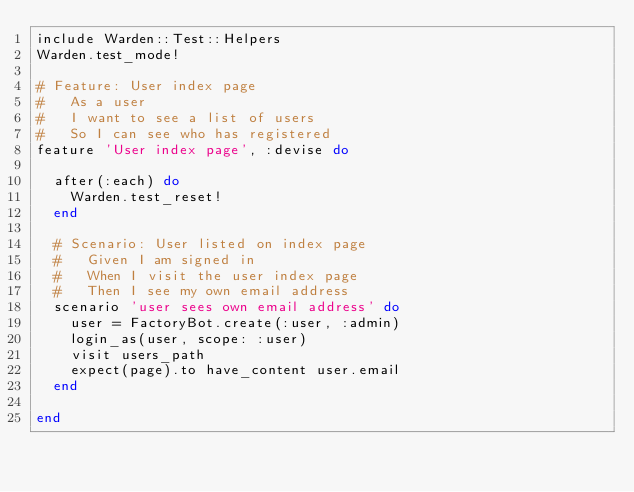<code> <loc_0><loc_0><loc_500><loc_500><_Ruby_>include Warden::Test::Helpers
Warden.test_mode!

# Feature: User index page
#   As a user
#   I want to see a list of users
#   So I can see who has registered
feature 'User index page', :devise do

  after(:each) do
    Warden.test_reset!
  end

  # Scenario: User listed on index page
  #   Given I am signed in
  #   When I visit the user index page
  #   Then I see my own email address
  scenario 'user sees own email address' do
    user = FactoryBot.create(:user, :admin)
    login_as(user, scope: :user)
    visit users_path
    expect(page).to have_content user.email
  end

end
</code> 